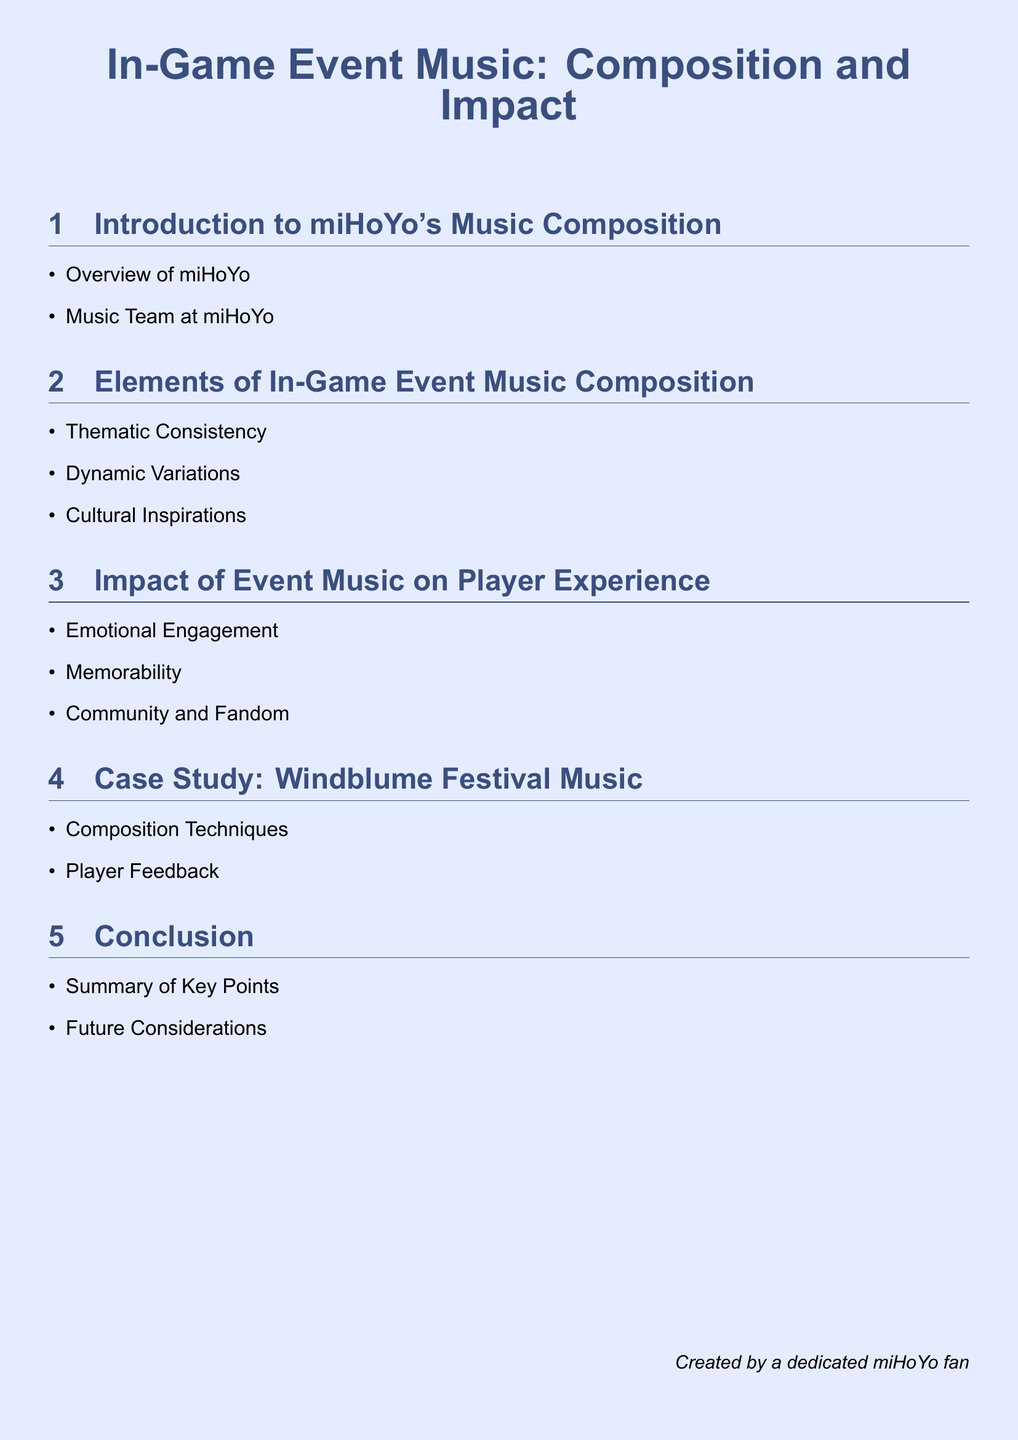What is the main topic of the document? The title of the document summarizes its main topic, which focuses on in-game event music, specifically its composition and impact in miHoYo games.
Answer: In-Game Event Music: Composition and Impact Who is the creator of this document? The document states the creator at the bottom, revealing their identity as a fan of miHoYo.
Answer: A dedicated miHoYo fan What is one of the elements of in-game event music composition? The document lists several elements of music composition, among them thematic consistency.
Answer: Thematic Consistency Which festival is used as a case study in the document? The case study section specifies a particular event associated with music to illustrate the topic.
Answer: Windblume Festival Music What aspect of player experience is highlighted in the document? The impact section emphasizes various benefits concerning how event music influences players.
Answer: Emotional Engagement What type of team does miHoYo have for music? The introduction mentions the organization and composition of the music team within miHoYo.
Answer: Music Team at miHoYo What is one benefit of memorable event music according to the document? The impact of event music references memorability as one of its positive effects on players.
Answer: Memorability What does the conclusion section summarize? The conclusion aims to encapsulate essential points discussed throughout the document.
Answer: Key Points 